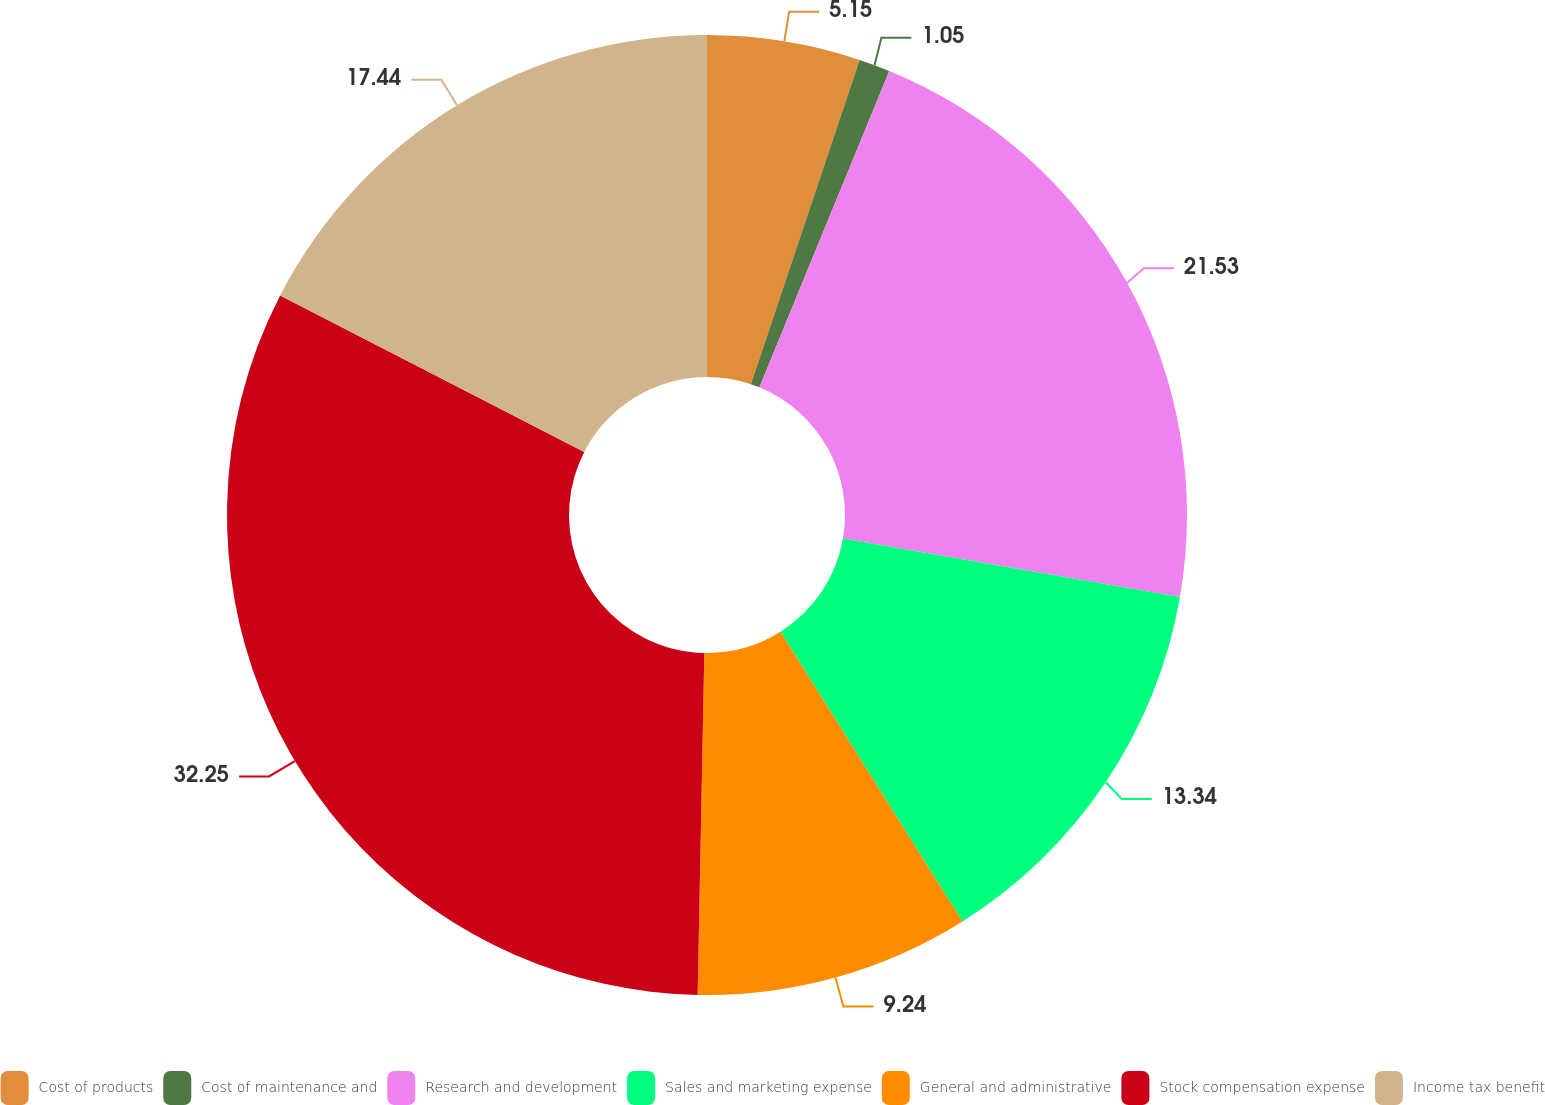Convert chart. <chart><loc_0><loc_0><loc_500><loc_500><pie_chart><fcel>Cost of products<fcel>Cost of maintenance and<fcel>Research and development<fcel>Sales and marketing expense<fcel>General and administrative<fcel>Stock compensation expense<fcel>Income tax benefit<nl><fcel>5.15%<fcel>1.05%<fcel>21.53%<fcel>13.34%<fcel>9.24%<fcel>32.25%<fcel>17.44%<nl></chart> 